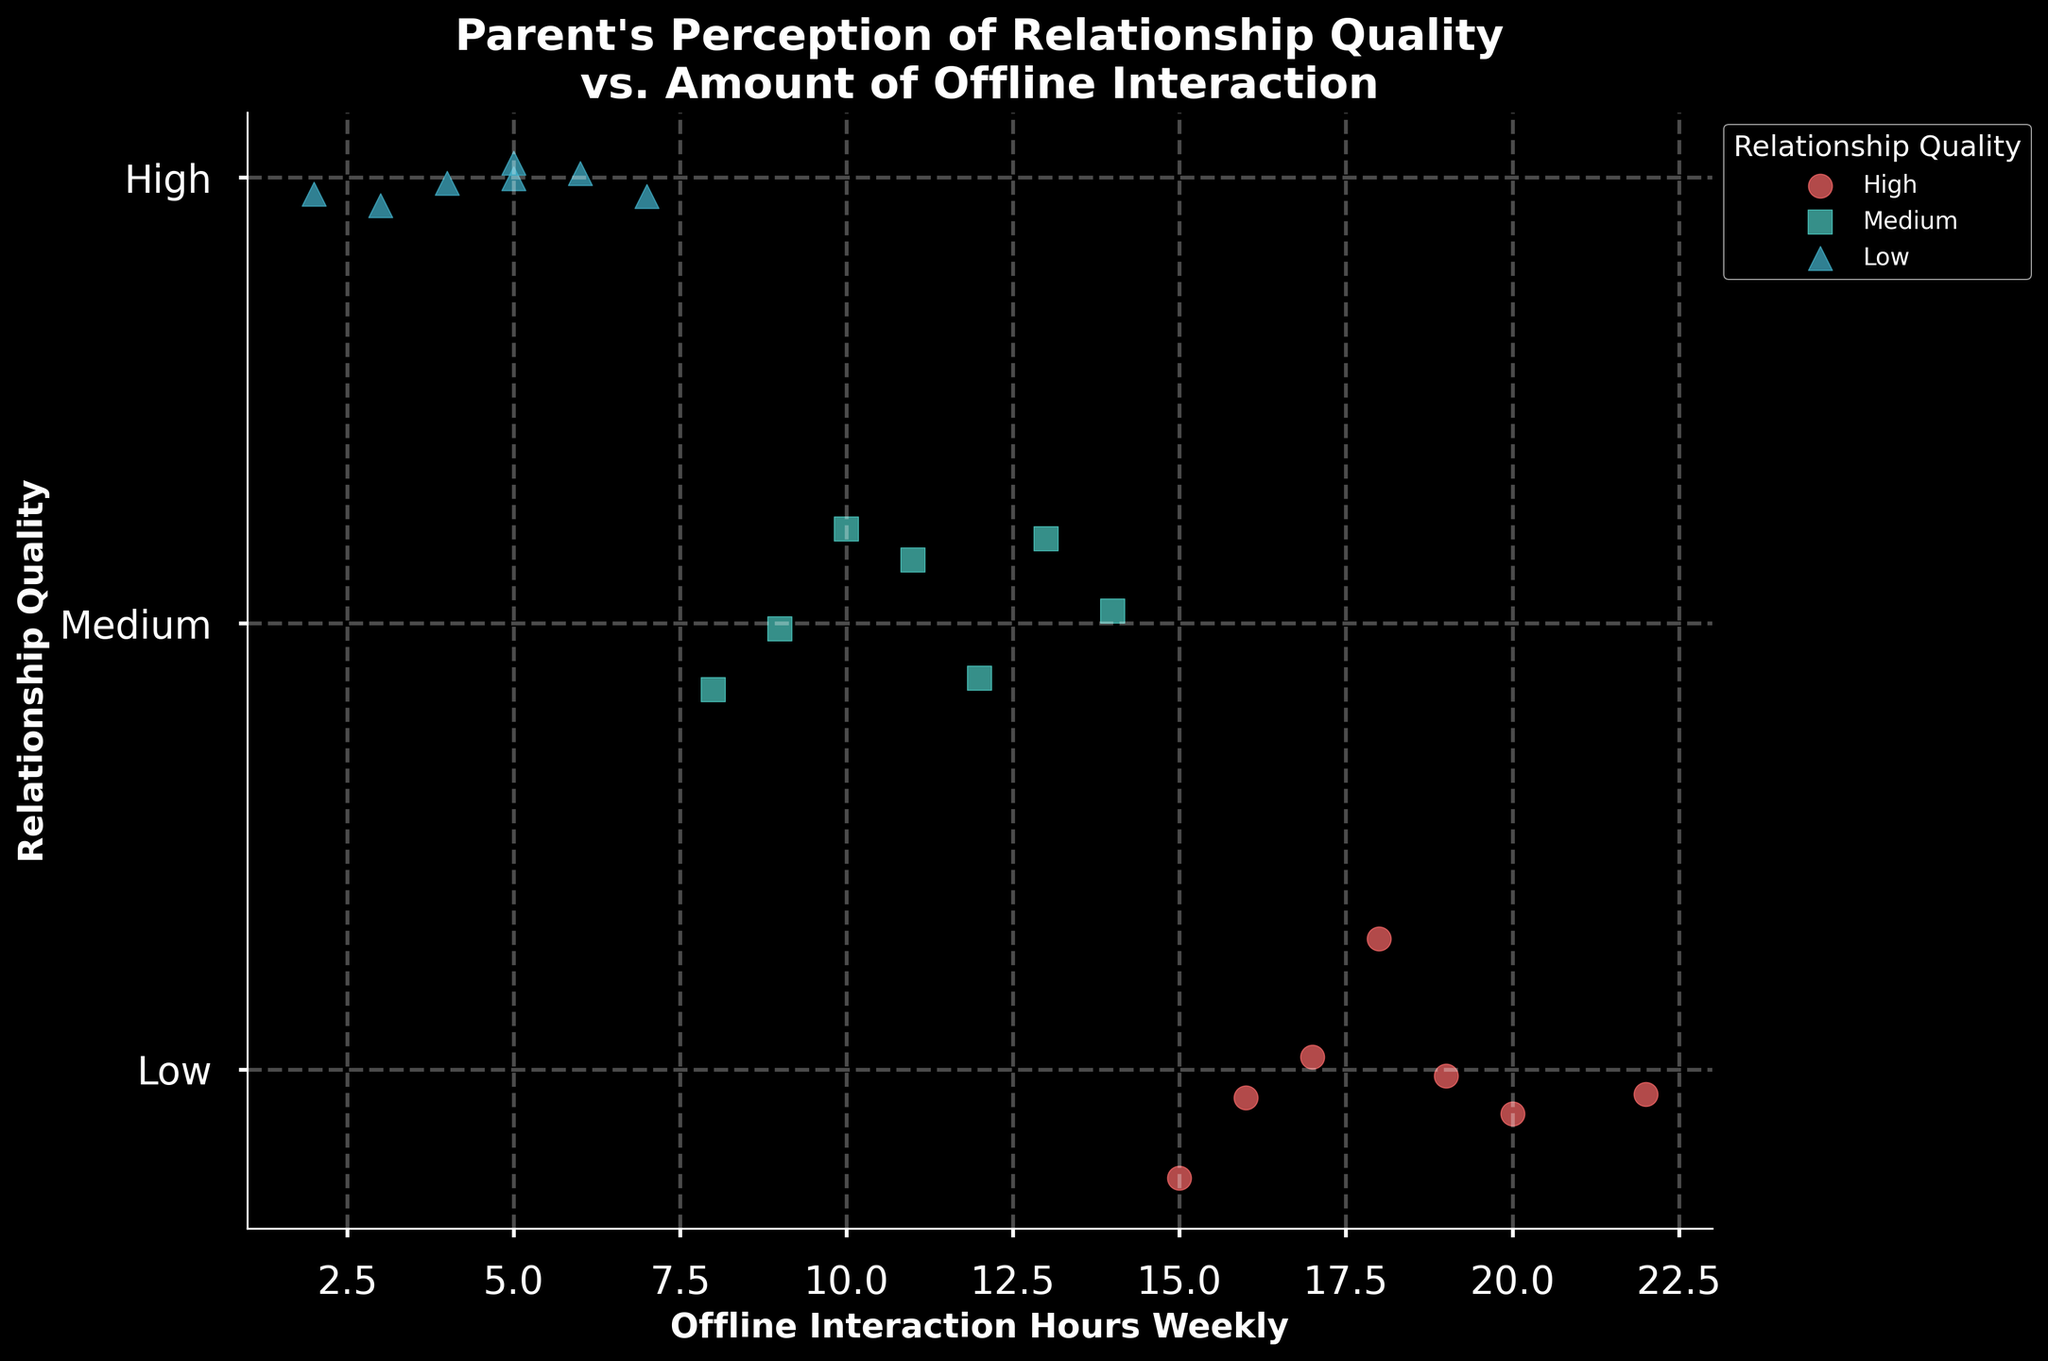What's the title of the figure? The title is displayed prominently at the top of the figure. It is "Parent's Perception of Relationship Quality vs. Amount of Offline Interaction".
Answer: Parent's Perception of Relationship Quality vs. Amount of Offline Interaction What is represented on the x-axis of the figure? The x-axis label indicates what is being measured along the horizontal axis. It is "Offline Interaction Hours Weekly".
Answer: Offline Interaction Hours Weekly What are the different relationship quality categories used in the figure? By looking at the legend, we can see three distinct categories of relationship quality: High, Medium, and Low. These are also represented by different colors and markers.
Answer: High, Medium, Low Which color represents 'High' relationship quality? Referring to the legend, the color associated with 'High' relationship quality is a distinctive color that stands out. It is red.
Answer: Red Among the parents with 'Low' relationship quality, what is the range of offline interaction hours weekly? By observing the scatter plot points marked for 'Low' quality on the x-axis, we can see that the range is from 2 to 7 hours.
Answer: 2 to 7 hours How many parents have 'High' relationship quality? Count the number of points on the scatter plot that are marked with the color red and are on the 'High' level. There are 7 data points.
Answer: 7 Do parents with 'Medium' relationship quality generally have more or less offline interaction hours than those with 'Low' relationship quality? By comparing the average positions of the 'Medium' (cyan squares) and 'Low' (blue triangles) markers along the x-axis, we can infer that 'Medium' generally has more offline interaction hours. On average, cyan squares are positioned more to the right.
Answer: More Which relationship quality category shows the widest range of offline interaction hours weekly? By comparing the spread of the points for each relationship quality category on the x-axis, we can see that the 'High' relationship quality spans from 15 to 22 hours, indicating the widest range.
Answer: High What is the average offline interaction hours weekly for parents with 'Medium' relationship quality? Sum the interaction hours for 'Medium' category (10+12+11+9+13+14+8) and divide by the number of data points (7). The calculation is (10+12+11+9+13+14+8)/7 = 11.
Answer: 11 Are there any overlapping points for different relationship qualities? Check for any scatter points that have the same x-axis value but different categories. There are no overlapping points between different categories.
Answer: No 